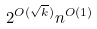<formula> <loc_0><loc_0><loc_500><loc_500>2 ^ { O ( \sqrt { k } ) } n ^ { O ( 1 ) }</formula> 